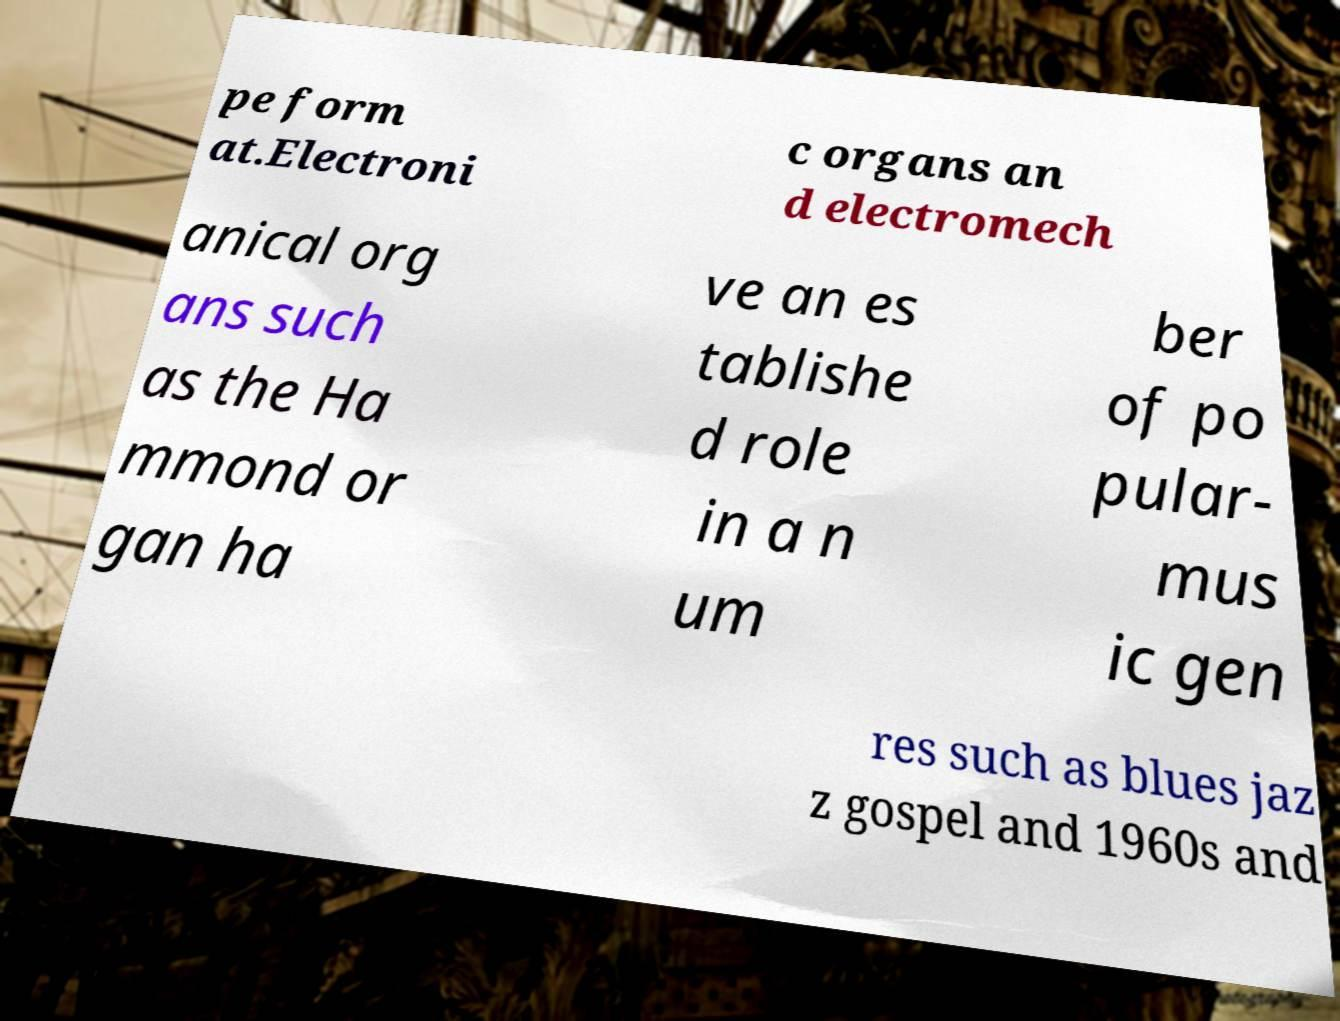Could you extract and type out the text from this image? pe form at.Electroni c organs an d electromech anical org ans such as the Ha mmond or gan ha ve an es tablishe d role in a n um ber of po pular- mus ic gen res such as blues jaz z gospel and 1960s and 